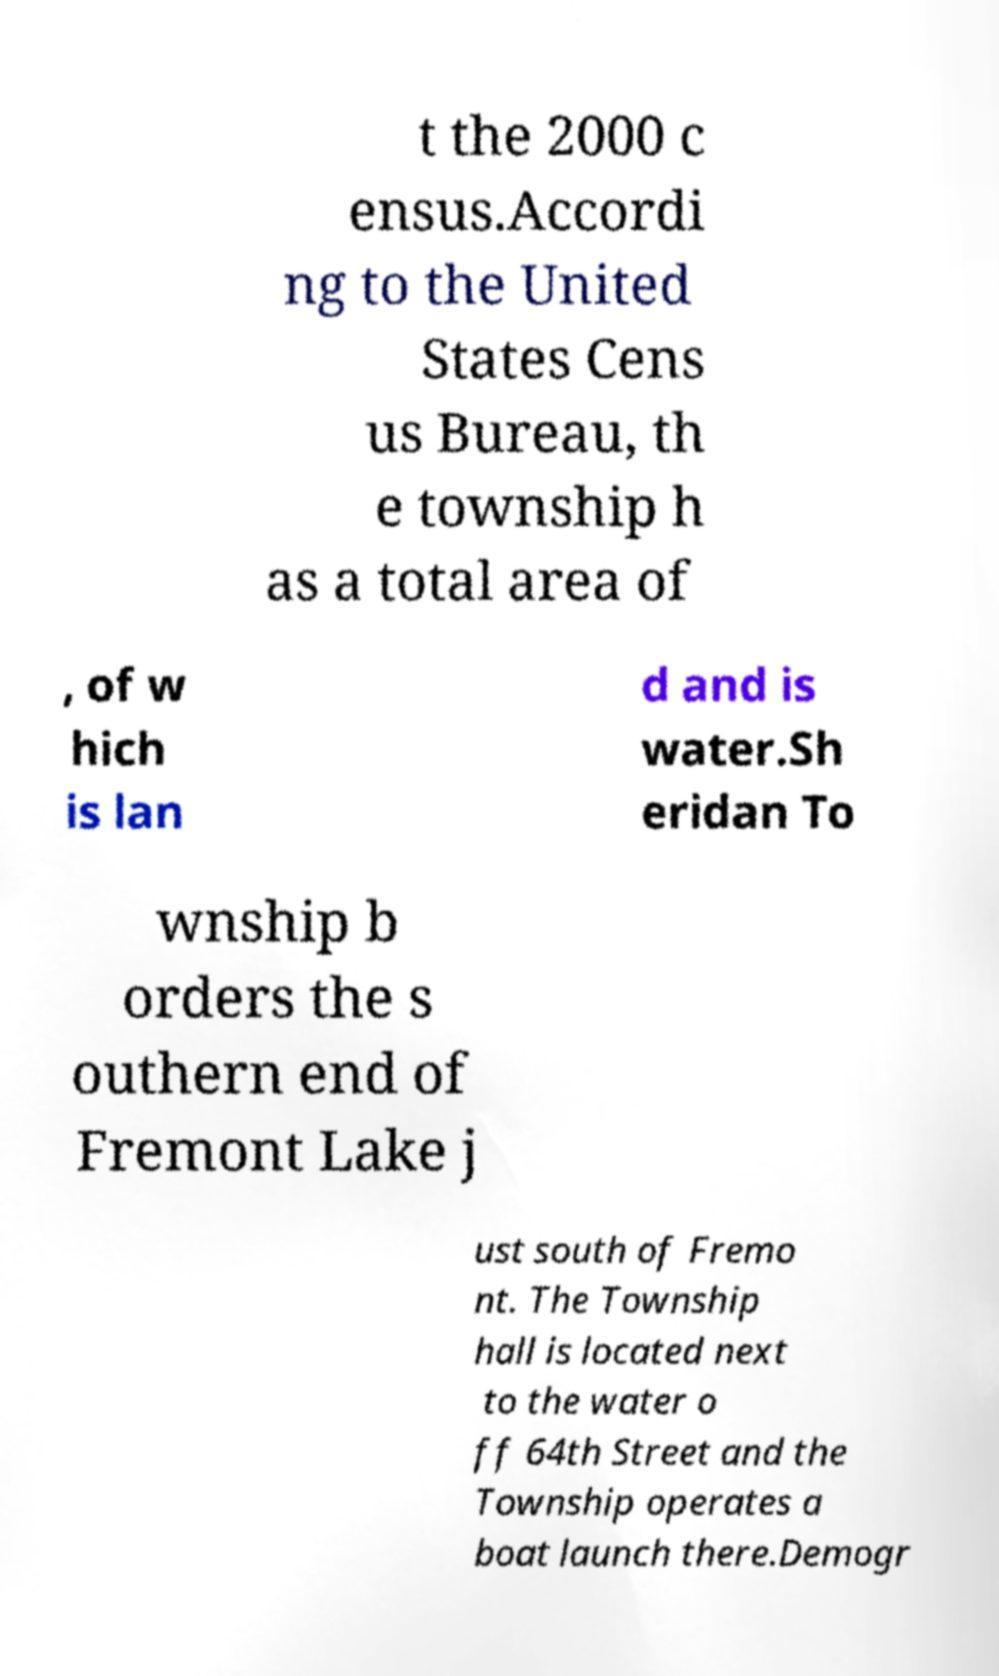Could you extract and type out the text from this image? t the 2000 c ensus.Accordi ng to the United States Cens us Bureau, th e township h as a total area of , of w hich is lan d and is water.Sh eridan To wnship b orders the s outhern end of Fremont Lake j ust south of Fremo nt. The Township hall is located next to the water o ff 64th Street and the Township operates a boat launch there.Demogr 